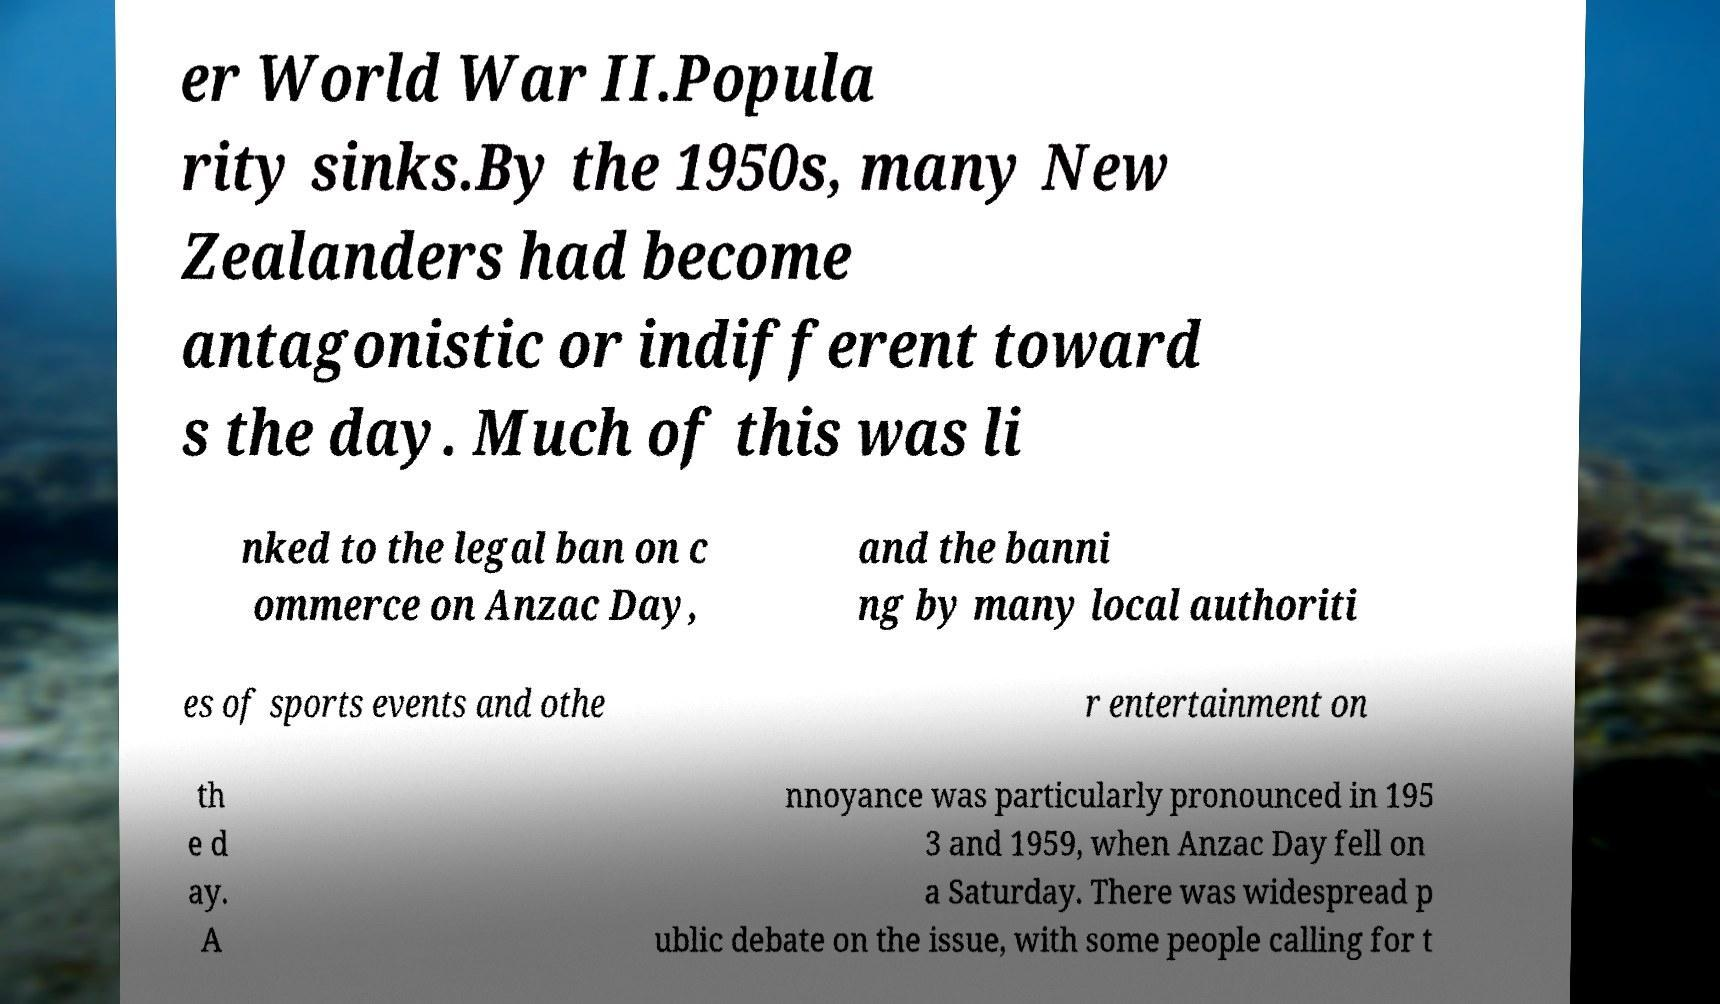Can you read and provide the text displayed in the image?This photo seems to have some interesting text. Can you extract and type it out for me? er World War II.Popula rity sinks.By the 1950s, many New Zealanders had become antagonistic or indifferent toward s the day. Much of this was li nked to the legal ban on c ommerce on Anzac Day, and the banni ng by many local authoriti es of sports events and othe r entertainment on th e d ay. A nnoyance was particularly pronounced in 195 3 and 1959, when Anzac Day fell on a Saturday. There was widespread p ublic debate on the issue, with some people calling for t 